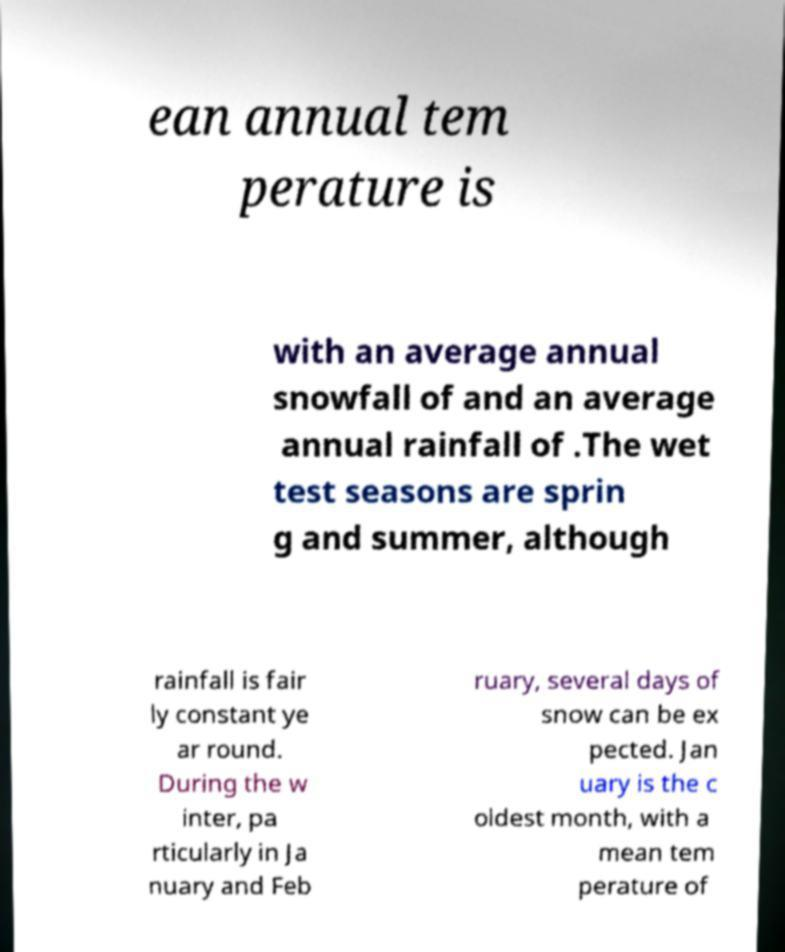Could you assist in decoding the text presented in this image and type it out clearly? ean annual tem perature is with an average annual snowfall of and an average annual rainfall of .The wet test seasons are sprin g and summer, although rainfall is fair ly constant ye ar round. During the w inter, pa rticularly in Ja nuary and Feb ruary, several days of snow can be ex pected. Jan uary is the c oldest month, with a mean tem perature of 